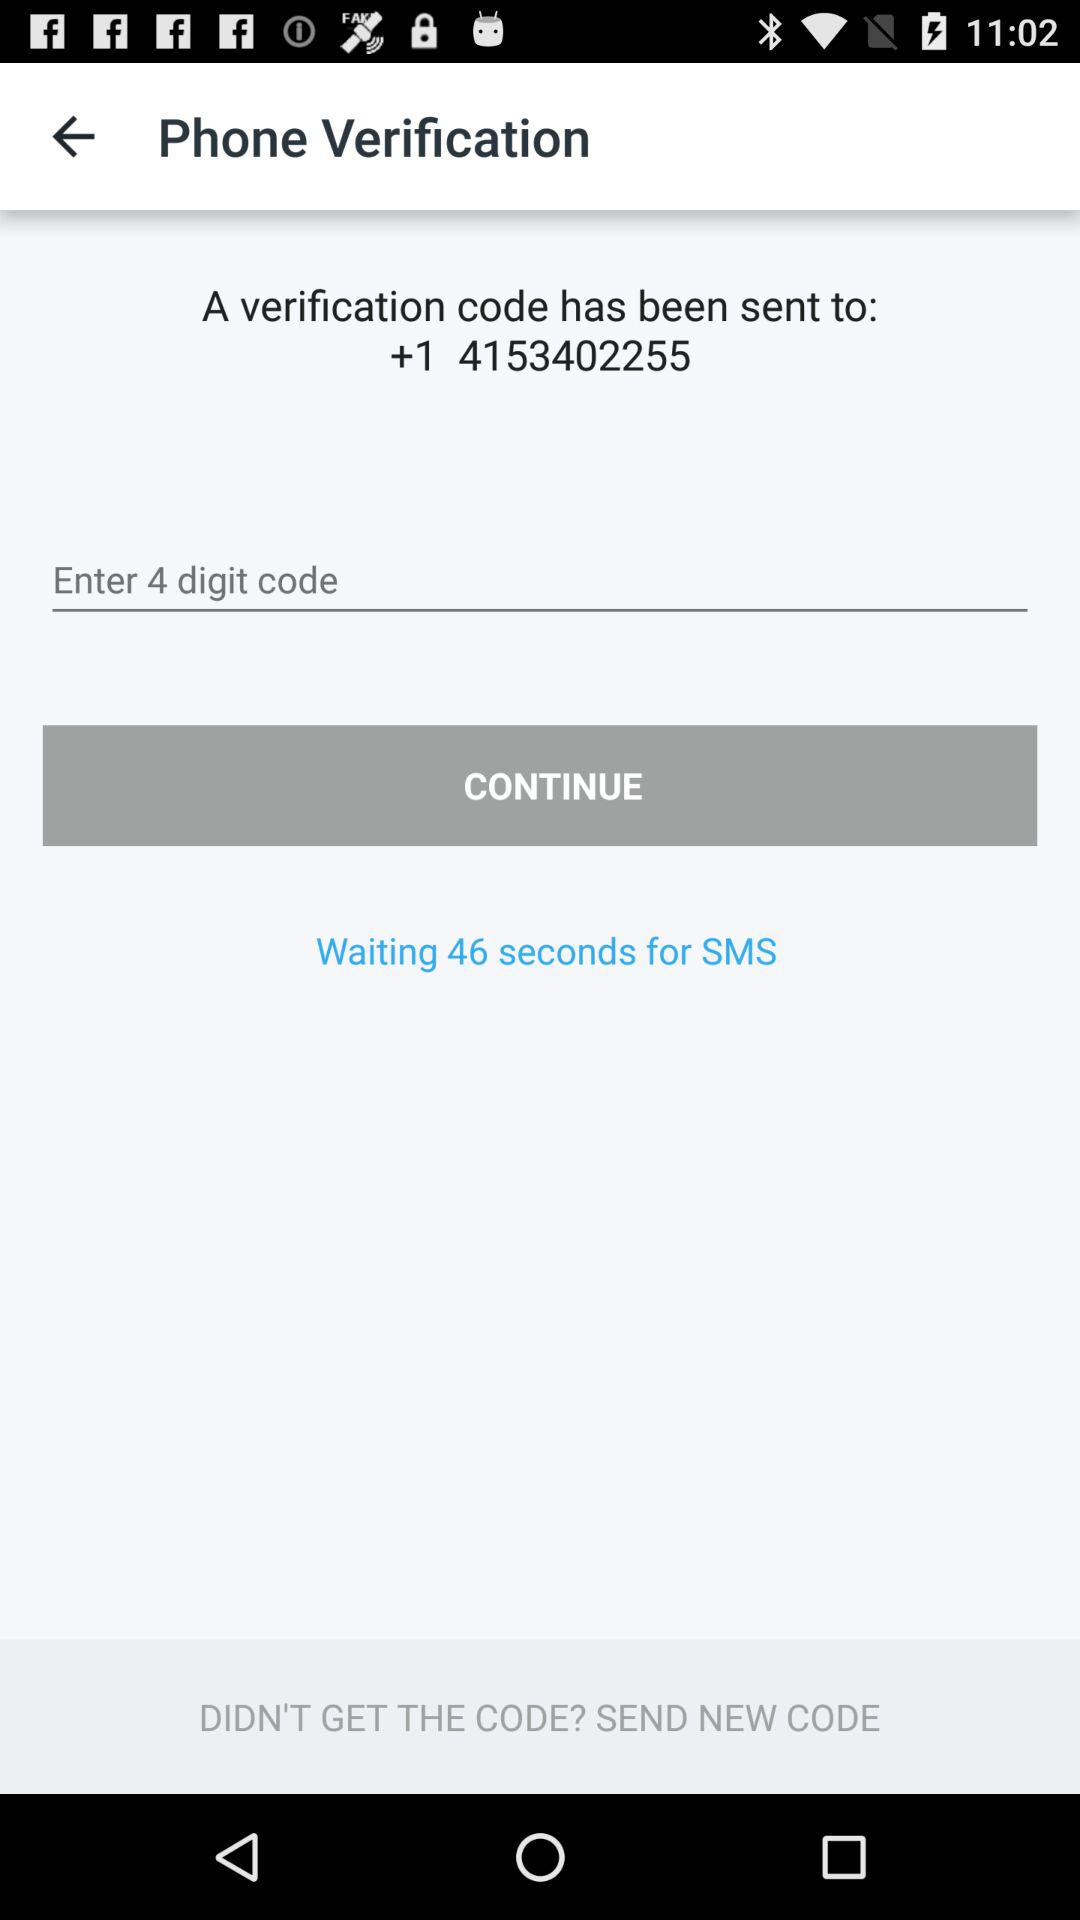How many digits are there in the code? There are 4 digits in the code. 